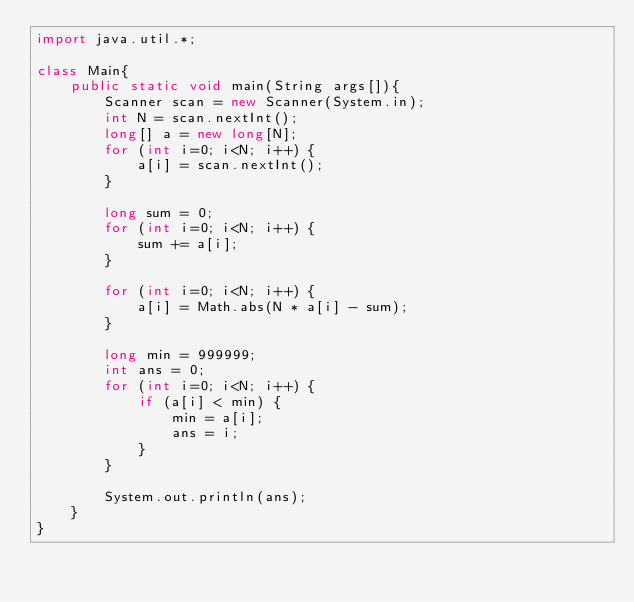<code> <loc_0><loc_0><loc_500><loc_500><_Java_>import java.util.*;

class Main{
    public static void main(String args[]){
        Scanner scan = new Scanner(System.in);
        int N = scan.nextInt();
        long[] a = new long[N];
        for (int i=0; i<N; i++) {
            a[i] = scan.nextInt();
        }

        long sum = 0;
        for (int i=0; i<N; i++) {
            sum += a[i];
        }

        for (int i=0; i<N; i++) {
            a[i] = Math.abs(N * a[i] - sum);
        }

        long min = 999999;
        int ans = 0;
        for (int i=0; i<N; i++) {
            if (a[i] < min) {
                min = a[i];
                ans = i;
            }
        }

        System.out.println(ans);
    }
}
</code> 